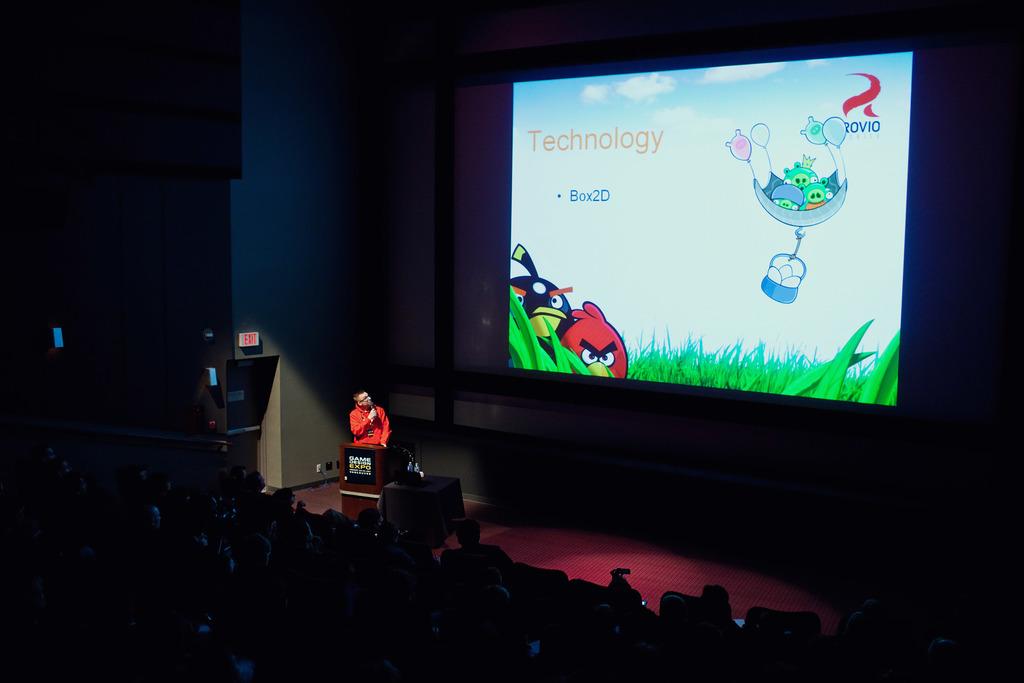What is the speaker's topic for this slide?
Offer a very short reply. Technology. What is the brand mentioned in the top right corner?
Provide a succinct answer. Rovio. 